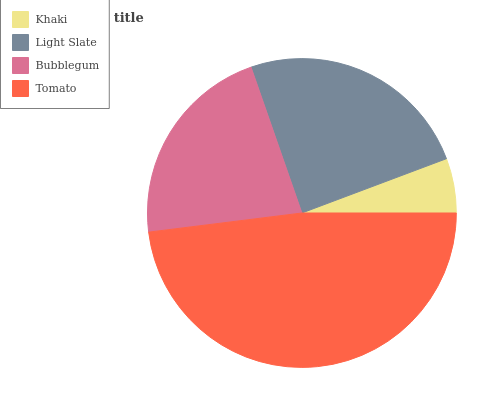Is Khaki the minimum?
Answer yes or no. Yes. Is Tomato the maximum?
Answer yes or no. Yes. Is Light Slate the minimum?
Answer yes or no. No. Is Light Slate the maximum?
Answer yes or no. No. Is Light Slate greater than Khaki?
Answer yes or no. Yes. Is Khaki less than Light Slate?
Answer yes or no. Yes. Is Khaki greater than Light Slate?
Answer yes or no. No. Is Light Slate less than Khaki?
Answer yes or no. No. Is Light Slate the high median?
Answer yes or no. Yes. Is Bubblegum the low median?
Answer yes or no. Yes. Is Khaki the high median?
Answer yes or no. No. Is Tomato the low median?
Answer yes or no. No. 